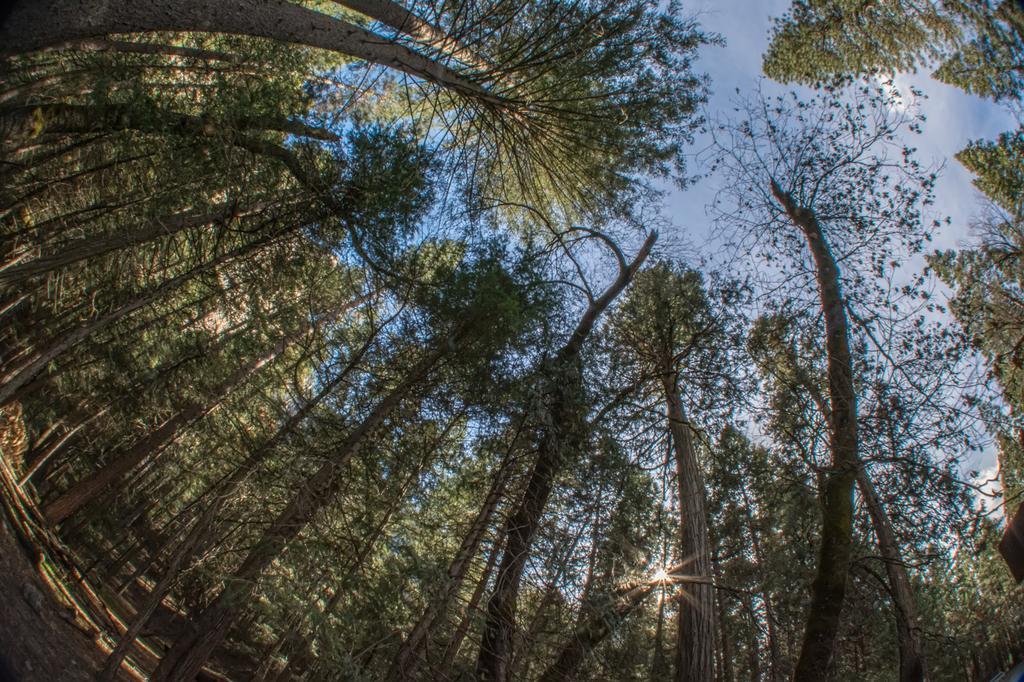Could you give a brief overview of what you see in this image? In the picture I can see the trees. There are clouds in the sky. 